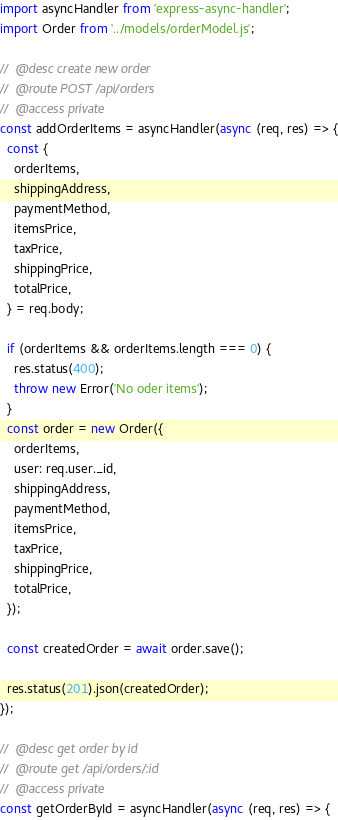Convert code to text. <code><loc_0><loc_0><loc_500><loc_500><_JavaScript_>import asyncHandler from 'express-async-handler';
import Order from '../models/orderModel.js';

//  @desc create new order
//  @route POST /api/orders
//  @access private
const addOrderItems = asyncHandler(async (req, res) => {
  const {
    orderItems,
    shippingAddress,
    paymentMethod,
    itemsPrice,
    taxPrice,
    shippingPrice,
    totalPrice,
  } = req.body;

  if (orderItems && orderItems.length === 0) {
    res.status(400);
    throw new Error('No oder items');
  }
  const order = new Order({
    orderItems,
    user: req.user._id,
    shippingAddress,
    paymentMethod,
    itemsPrice,
    taxPrice,
    shippingPrice,
    totalPrice,
  });

  const createdOrder = await order.save();

  res.status(201).json(createdOrder);
});

//  @desc get order by id
//  @route get /api/orders/:id
//  @access private
const getOrderById = asyncHandler(async (req, res) => {</code> 